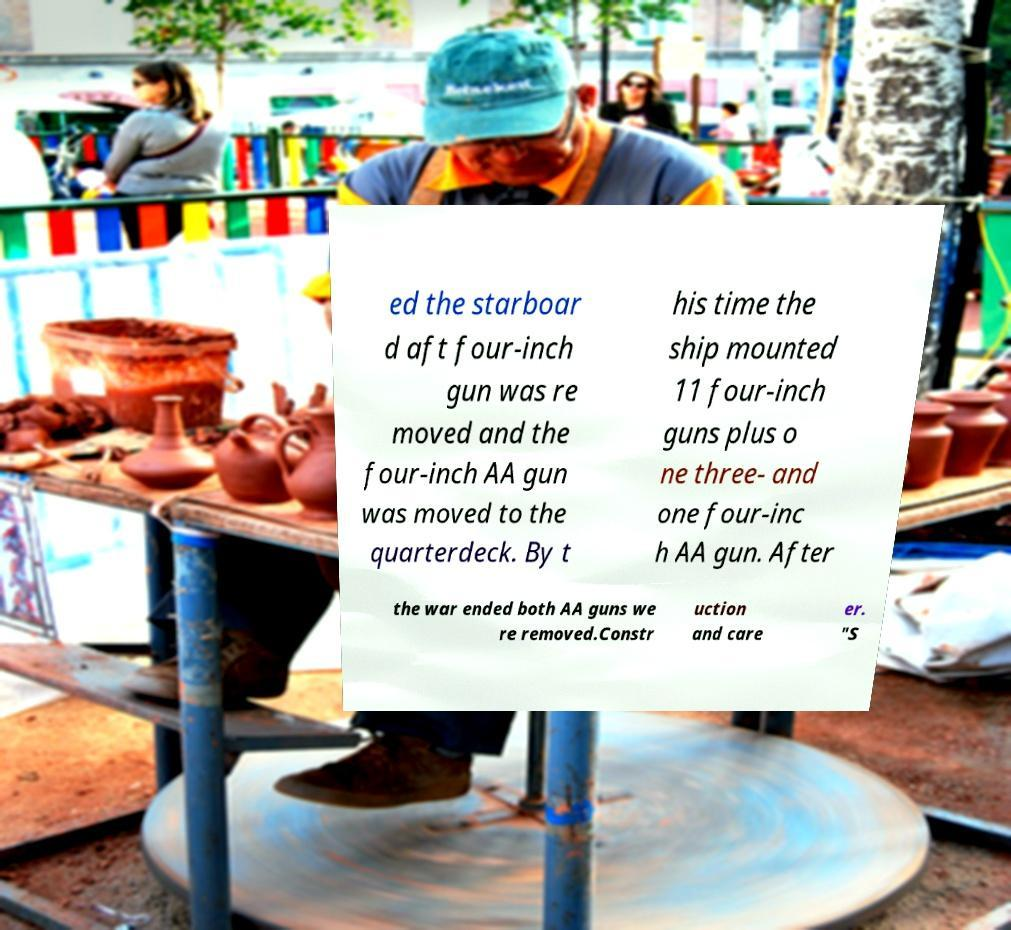Please identify and transcribe the text found in this image. ed the starboar d aft four-inch gun was re moved and the four-inch AA gun was moved to the quarterdeck. By t his time the ship mounted 11 four-inch guns plus o ne three- and one four-inc h AA gun. After the war ended both AA guns we re removed.Constr uction and care er. "S 